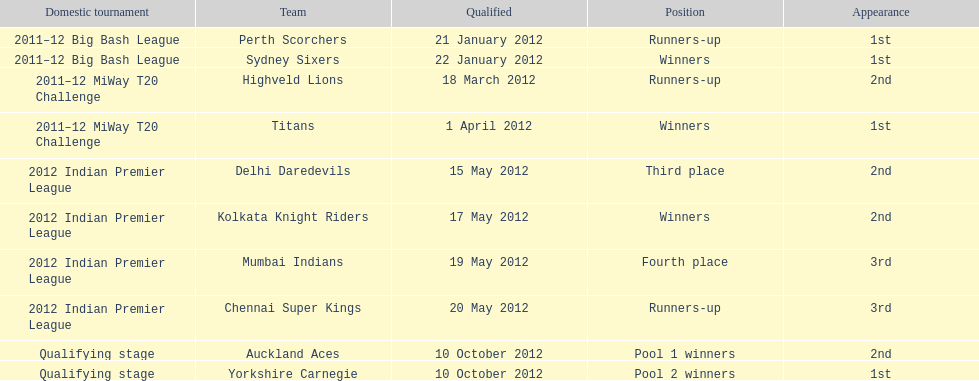Which team made their first appearance in the same tournament as the perth scorchers? Sydney Sixers. I'm looking to parse the entire table for insights. Could you assist me with that? {'header': ['Domestic tournament', 'Team', 'Qualified', 'Position', 'Appearance'], 'rows': [['2011–12 Big Bash League', 'Perth Scorchers', '21 January 2012', 'Runners-up', '1st'], ['2011–12 Big Bash League', 'Sydney Sixers', '22 January 2012', 'Winners', '1st'], ['2011–12 MiWay T20 Challenge', 'Highveld Lions', '18 March 2012', 'Runners-up', '2nd'], ['2011–12 MiWay T20 Challenge', 'Titans', '1 April 2012', 'Winners', '1st'], ['2012 Indian Premier League', 'Delhi Daredevils', '15 May 2012', 'Third place', '2nd'], ['2012 Indian Premier League', 'Kolkata Knight Riders', '17 May 2012', 'Winners', '2nd'], ['2012 Indian Premier League', 'Mumbai Indians', '19 May 2012', 'Fourth place', '3rd'], ['2012 Indian Premier League', 'Chennai Super Kings', '20 May 2012', 'Runners-up', '3rd'], ['Qualifying stage', 'Auckland Aces', '10 October 2012', 'Pool 1 winners', '2nd'], ['Qualifying stage', 'Yorkshire Carnegie', '10 October 2012', 'Pool 2 winners', '1st']]} 